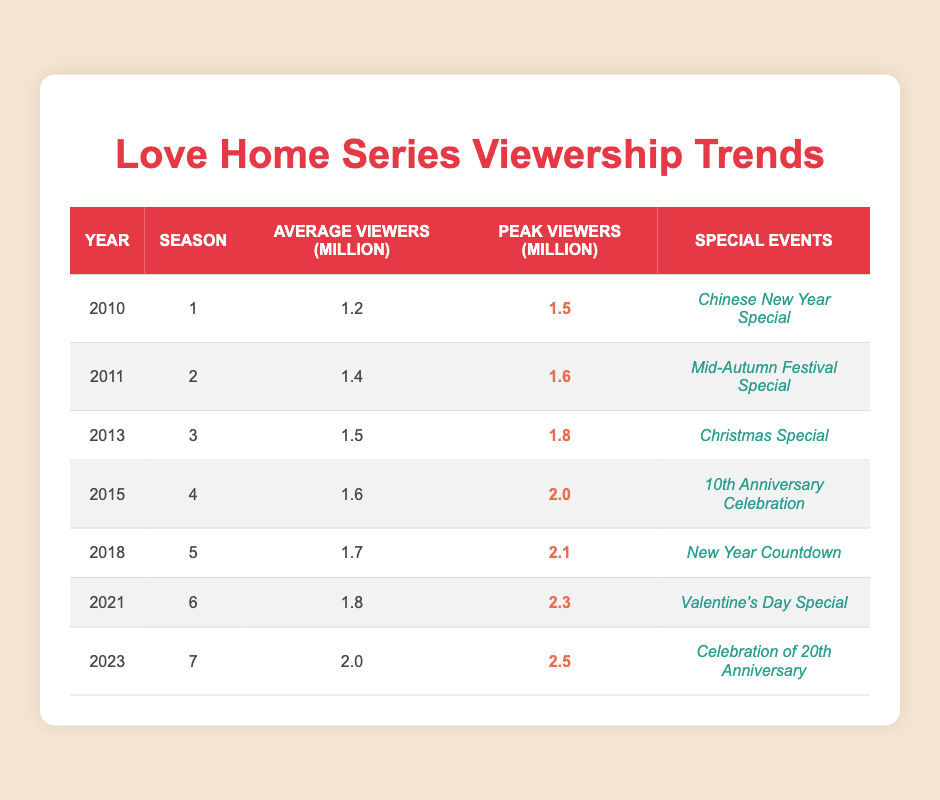What was the peak viewership for Season 5 in 2018? The peak viewership for Season 5 in 2018 is listed in the table as 2.1 million.
Answer: 2.1 million Which season had the highest average viewers? In the table, Season 7 in 2023 shows the highest average viewers at 2.0 million.
Answer: 2.0 million How many million average viewers did the show gain from 2010 to 2021? The average viewers in 2010 were 1.2 million and in 2021 were 1.8 million. The difference is 1.8 - 1.2 = 0.6 million.
Answer: 0.6 million Did Season 3 have a greater peak viewership than Season 4? The peak viewership for Season 3 in 2013 is 1.8 million, and for Season 4 in 2015 it is 2.0 million. Since 1.8 million is less than 2.0 million, the statement is false.
Answer: No Which special event corresponded with the highest peak viewership? The table indicates that the highest peak viewership was 2.5 million for Season 7 in 2023, associated with the "Celebration of 20th Anniversary" special event.
Answer: Celebration of 20th Anniversary What is the average viewership across all seasons listed? To find the average, sum the average viewers for all seasons: (1.2 + 1.4 + 1.5 + 1.6 + 1.7 + 1.8 + 2.0) = 10.2 million. There are 7 seasons, so 10.2 / 7 = 1.46 million average viewers.
Answer: 1.46 million Which season’s special event was the "Valentine's Day Special"? According to the table, the "Valentine's Day Special" corresponds with Season 6 in 2021.
Answer: Season 6 How much did the average viewership increase from Season 1 to Season 7? Season 1 (2010) had an average viewership of 1.2 million, and Season 7 (2023) had 2.0 million. The increase is calculated as 2.0 - 1.2 = 0.8 million.
Answer: 0.8 million In which year was the "Chinese New Year Special" aired? The "Chinese New Year Special" is associated with Season 1, which aired in 2010 as per the table.
Answer: 2010 